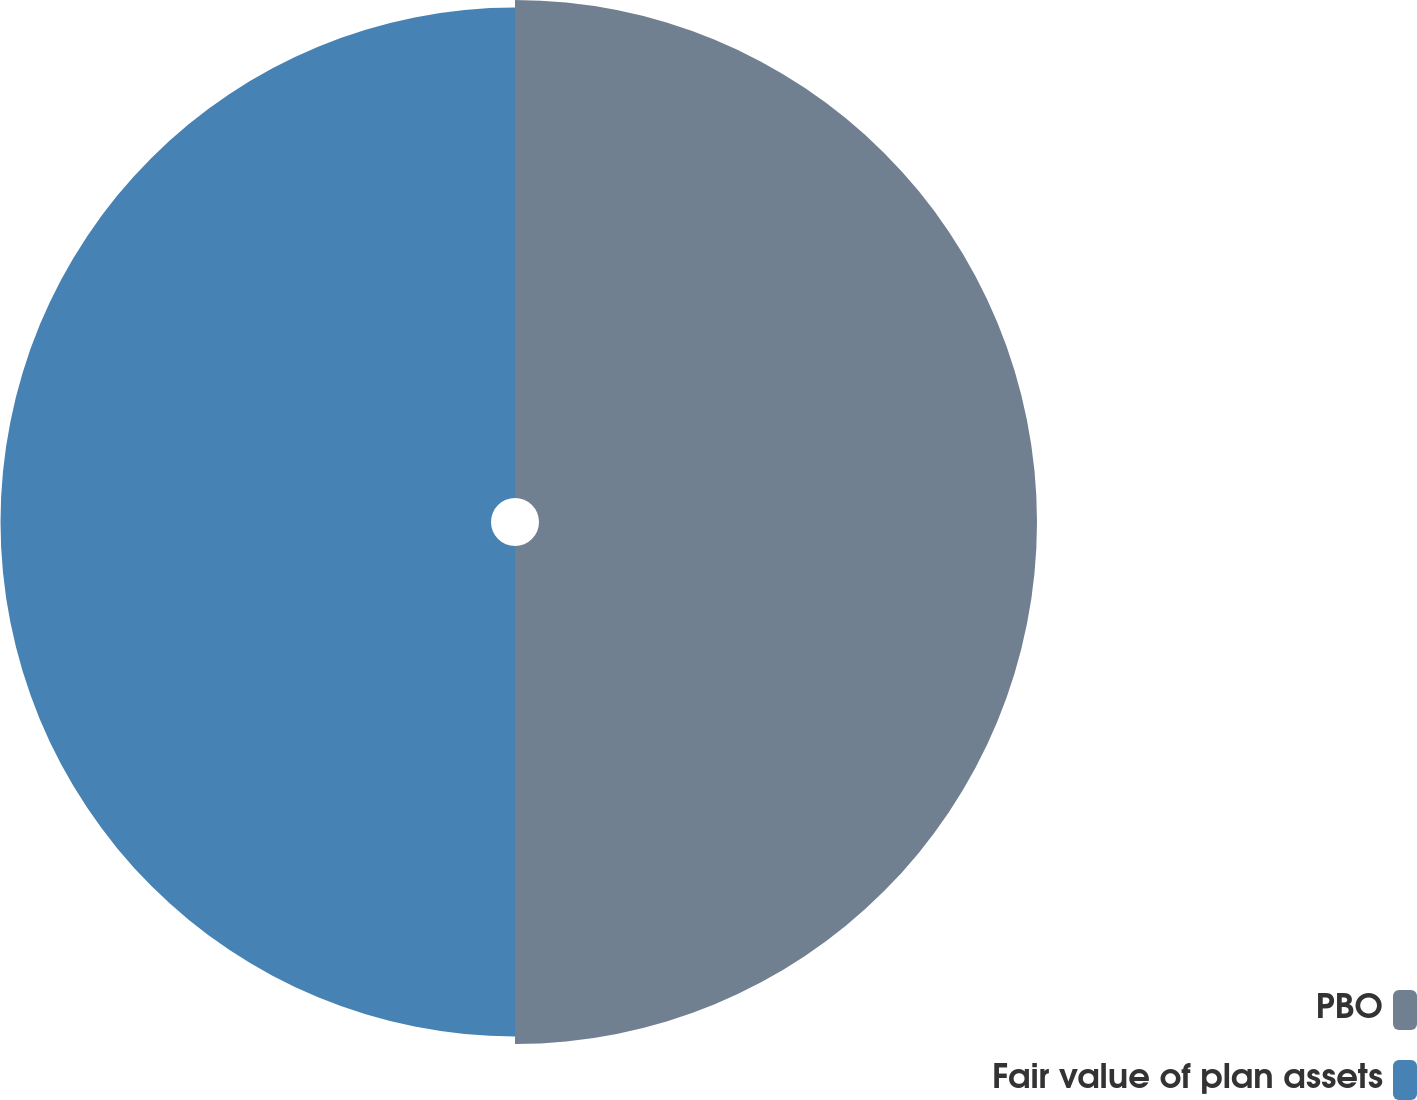Convert chart to OTSL. <chart><loc_0><loc_0><loc_500><loc_500><pie_chart><fcel>PBO<fcel>Fair value of plan assets<nl><fcel>50.38%<fcel>49.62%<nl></chart> 